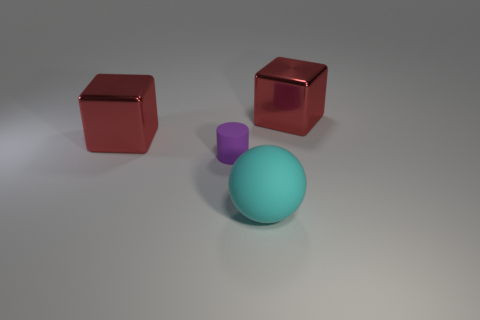How many things are rubber objects in front of the purple rubber thing or objects that are behind the tiny rubber object? In the image, there are two rubber objects in front of the purple rubber cube but none behind the tiny rubber cube. Thus, including the purple cube itself, there are a total of three rubber objects visible. 